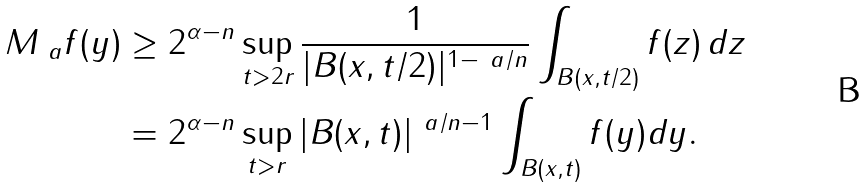<formula> <loc_0><loc_0><loc_500><loc_500>M _ { \ a } f ( y ) & \geq 2 ^ { \alpha - n } \sup _ { t > 2 r } \frac { 1 } { | B ( x , { t } / { 2 } ) | ^ { 1 - \ a / n } } \int _ { B ( x , { t } / { 2 } ) } f ( z ) \, d z \\ & = 2 ^ { \alpha - n } \sup _ { t > r } | B ( x , t ) | ^ { \ a / n - 1 } \int _ { B ( x , t ) } f ( y ) d y .</formula> 